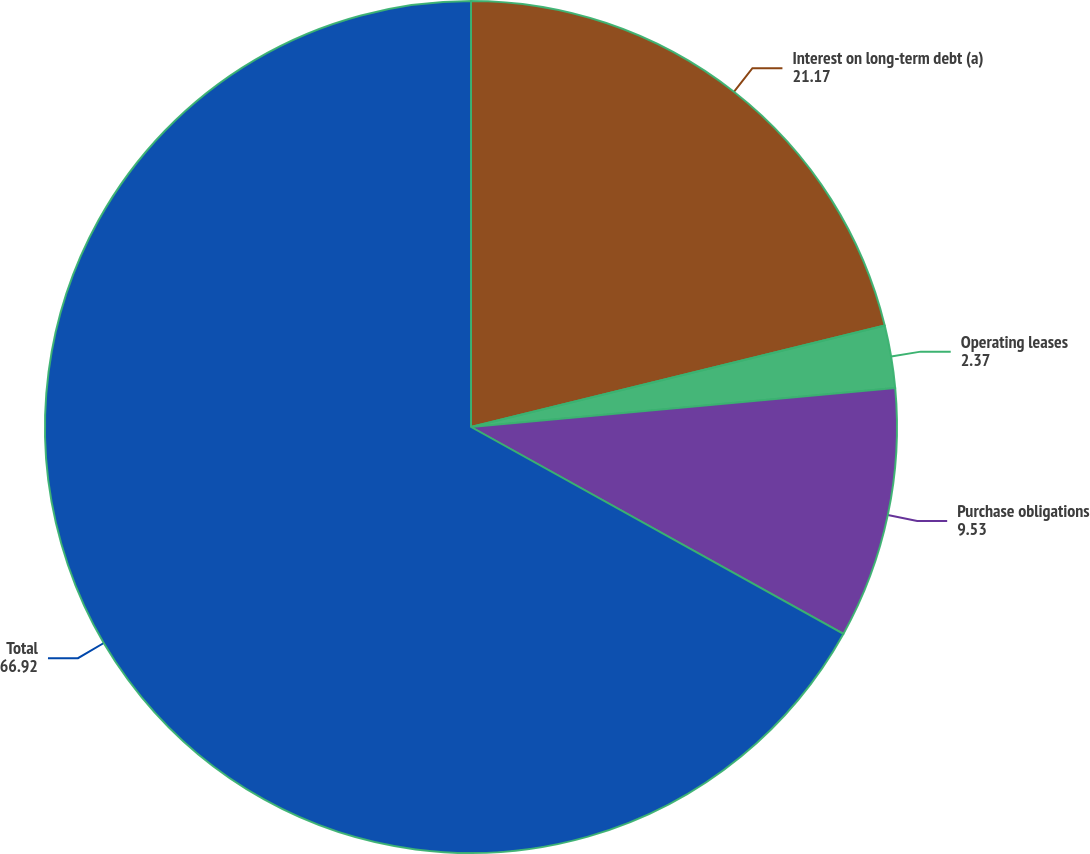Convert chart to OTSL. <chart><loc_0><loc_0><loc_500><loc_500><pie_chart><fcel>Interest on long-term debt (a)<fcel>Operating leases<fcel>Purchase obligations<fcel>Total<nl><fcel>21.17%<fcel>2.37%<fcel>9.53%<fcel>66.92%<nl></chart> 